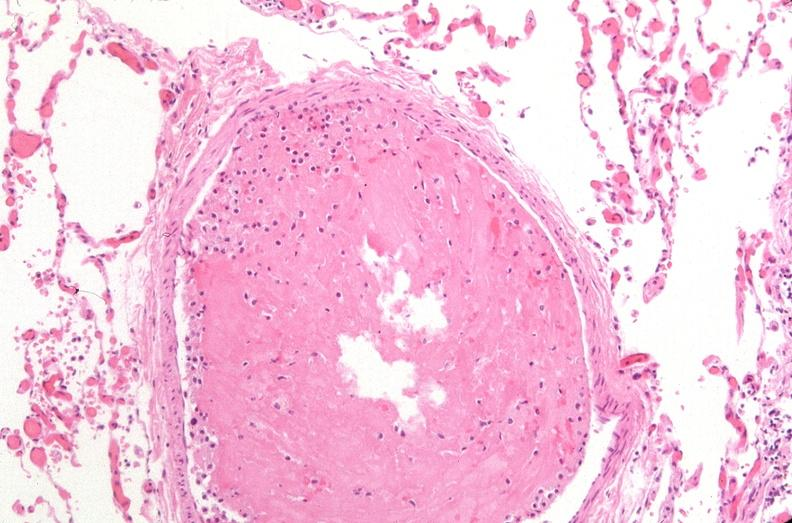does this image show lung, organizing thromboembolus?
Answer the question using a single word or phrase. Yes 